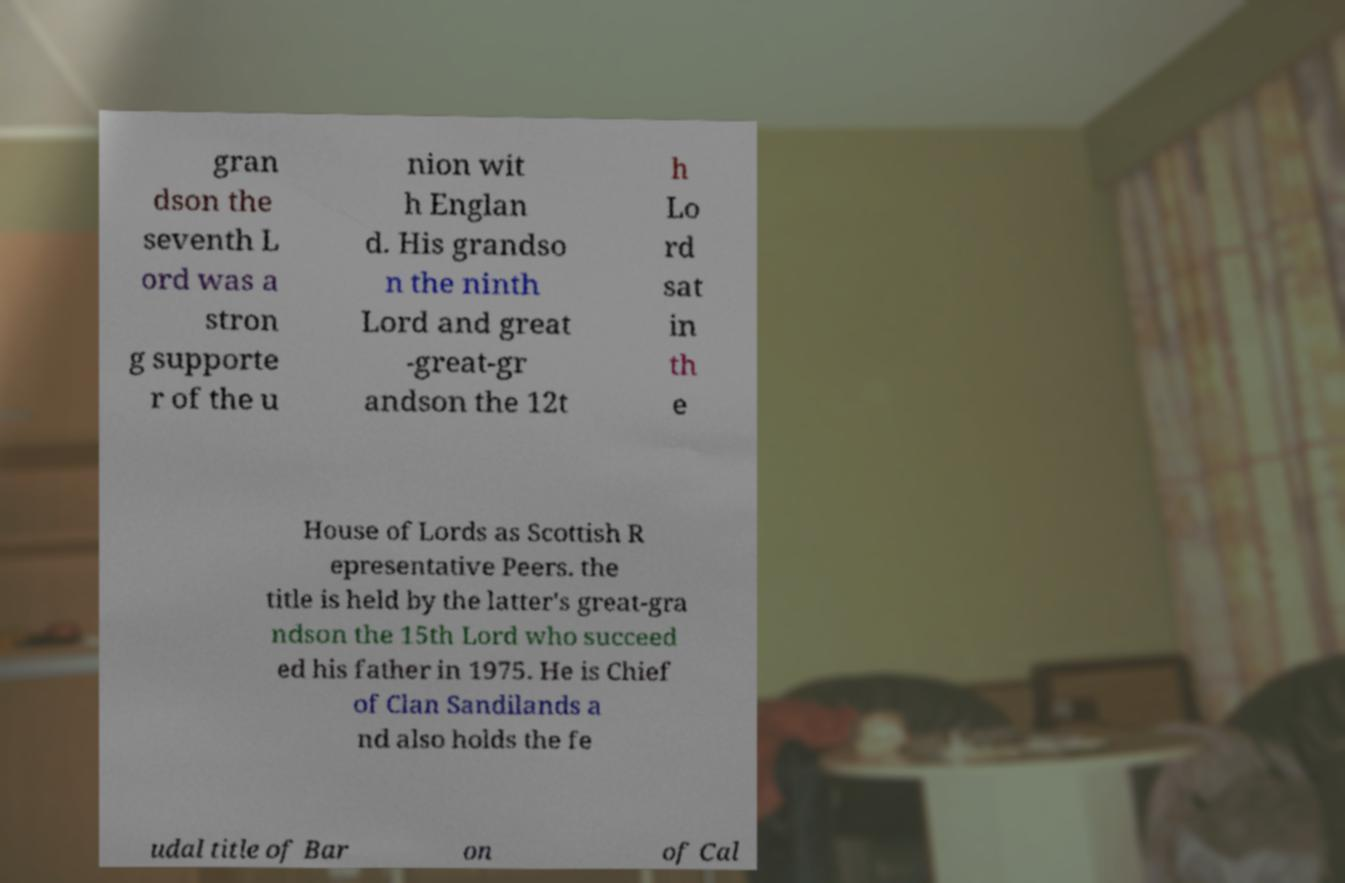Can you accurately transcribe the text from the provided image for me? gran dson the seventh L ord was a stron g supporte r of the u nion wit h Englan d. His grandso n the ninth Lord and great -great-gr andson the 12t h Lo rd sat in th e House of Lords as Scottish R epresentative Peers. the title is held by the latter's great-gra ndson the 15th Lord who succeed ed his father in 1975. He is Chief of Clan Sandilands a nd also holds the fe udal title of Bar on of Cal 